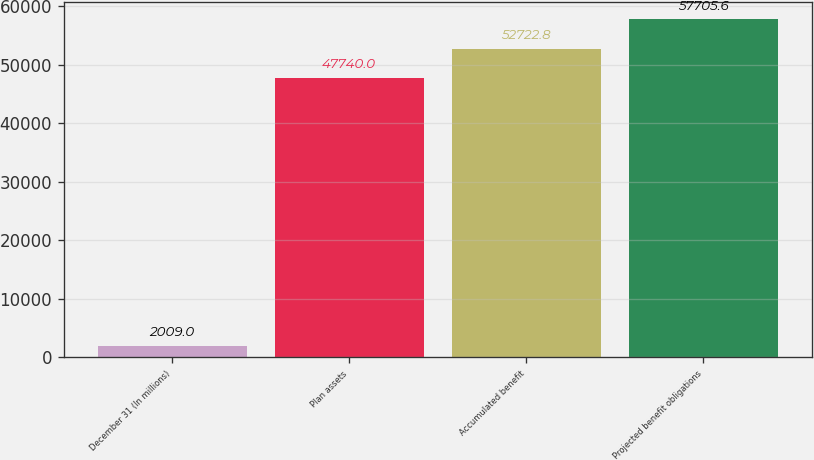Convert chart. <chart><loc_0><loc_0><loc_500><loc_500><bar_chart><fcel>December 31 (In millions)<fcel>Plan assets<fcel>Accumulated benefit<fcel>Projected benefit obligations<nl><fcel>2009<fcel>47740<fcel>52722.8<fcel>57705.6<nl></chart> 